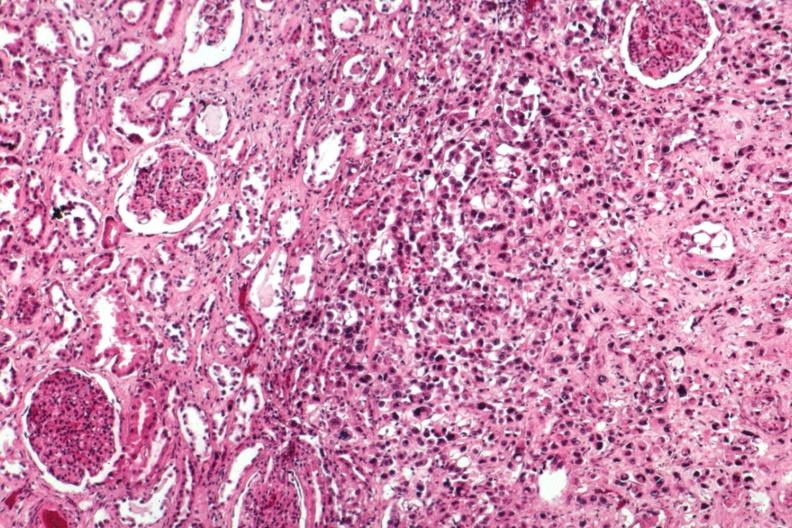what is present?
Answer the question using a single word or phrase. Kidney 